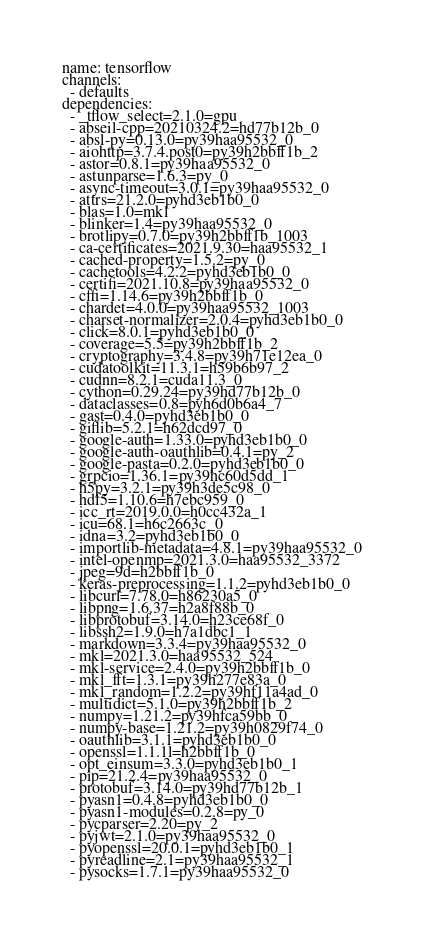<code> <loc_0><loc_0><loc_500><loc_500><_YAML_>name: tensorflow
channels:
  - defaults
dependencies:
  - _tflow_select=2.1.0=gpu
  - abseil-cpp=20210324.2=hd77b12b_0
  - absl-py=0.13.0=py39haa95532_0
  - aiohttp=3.7.4.post0=py39h2bbff1b_2
  - astor=0.8.1=py39haa95532_0
  - astunparse=1.6.3=py_0
  - async-timeout=3.0.1=py39haa95532_0
  - attrs=21.2.0=pyhd3eb1b0_0
  - blas=1.0=mkl
  - blinker=1.4=py39haa95532_0
  - brotlipy=0.7.0=py39h2bbff1b_1003
  - ca-certificates=2021.9.30=haa95532_1
  - cached-property=1.5.2=py_0
  - cachetools=4.2.2=pyhd3eb1b0_0
  - certifi=2021.10.8=py39haa95532_0
  - cffi=1.14.6=py39h2bbff1b_0
  - chardet=4.0.0=py39haa95532_1003
  - charset-normalizer=2.0.4=pyhd3eb1b0_0
  - click=8.0.1=pyhd3eb1b0_0
  - coverage=5.5=py39h2bbff1b_2
  - cryptography=3.4.8=py39h71e12ea_0
  - cudatoolkit=11.3.1=h59b6b97_2
  - cudnn=8.2.1=cuda11.3_0
  - cython=0.29.24=py39hd77b12b_0
  - dataclasses=0.8=pyh6d0b6a4_7
  - gast=0.4.0=pyhd3eb1b0_0
  - giflib=5.2.1=h62dcd97_0
  - google-auth=1.33.0=pyhd3eb1b0_0
  - google-auth-oauthlib=0.4.1=py_2
  - google-pasta=0.2.0=pyhd3eb1b0_0
  - grpcio=1.36.1=py39hc60d5dd_1
  - h5py=3.2.1=py39h3de5c98_0
  - hdf5=1.10.6=h7ebc959_0
  - icc_rt=2019.0.0=h0cc432a_1
  - icu=68.1=h6c2663c_0
  - idna=3.2=pyhd3eb1b0_0
  - importlib-metadata=4.8.1=py39haa95532_0
  - intel-openmp=2021.3.0=haa95532_3372
  - jpeg=9d=h2bbff1b_0
  - keras-preprocessing=1.1.2=pyhd3eb1b0_0
  - libcurl=7.78.0=h86230a5_0
  - libpng=1.6.37=h2a8f88b_0
  - libprotobuf=3.14.0=h23ce68f_0
  - libssh2=1.9.0=h7a1dbc1_1
  - markdown=3.3.4=py39haa95532_0
  - mkl=2021.3.0=haa95532_524
  - mkl-service=2.4.0=py39h2bbff1b_0
  - mkl_fft=1.3.1=py39h277e83a_0
  - mkl_random=1.2.2=py39hf11a4ad_0
  - multidict=5.1.0=py39h2bbff1b_2
  - numpy=1.21.2=py39hfca59bb_0
  - numpy-base=1.21.2=py39h0829f74_0
  - oauthlib=3.1.1=pyhd3eb1b0_0
  - openssl=1.1.1l=h2bbff1b_0
  - opt_einsum=3.3.0=pyhd3eb1b0_1
  - pip=21.2.4=py39haa95532_0
  - protobuf=3.14.0=py39hd77b12b_1
  - pyasn1=0.4.8=pyhd3eb1b0_0
  - pyasn1-modules=0.2.8=py_0
  - pycparser=2.20=py_2
  - pyjwt=2.1.0=py39haa95532_0
  - pyopenssl=20.0.1=pyhd3eb1b0_1
  - pyreadline=2.1=py39haa95532_1
  - pysocks=1.7.1=py39haa95532_0</code> 